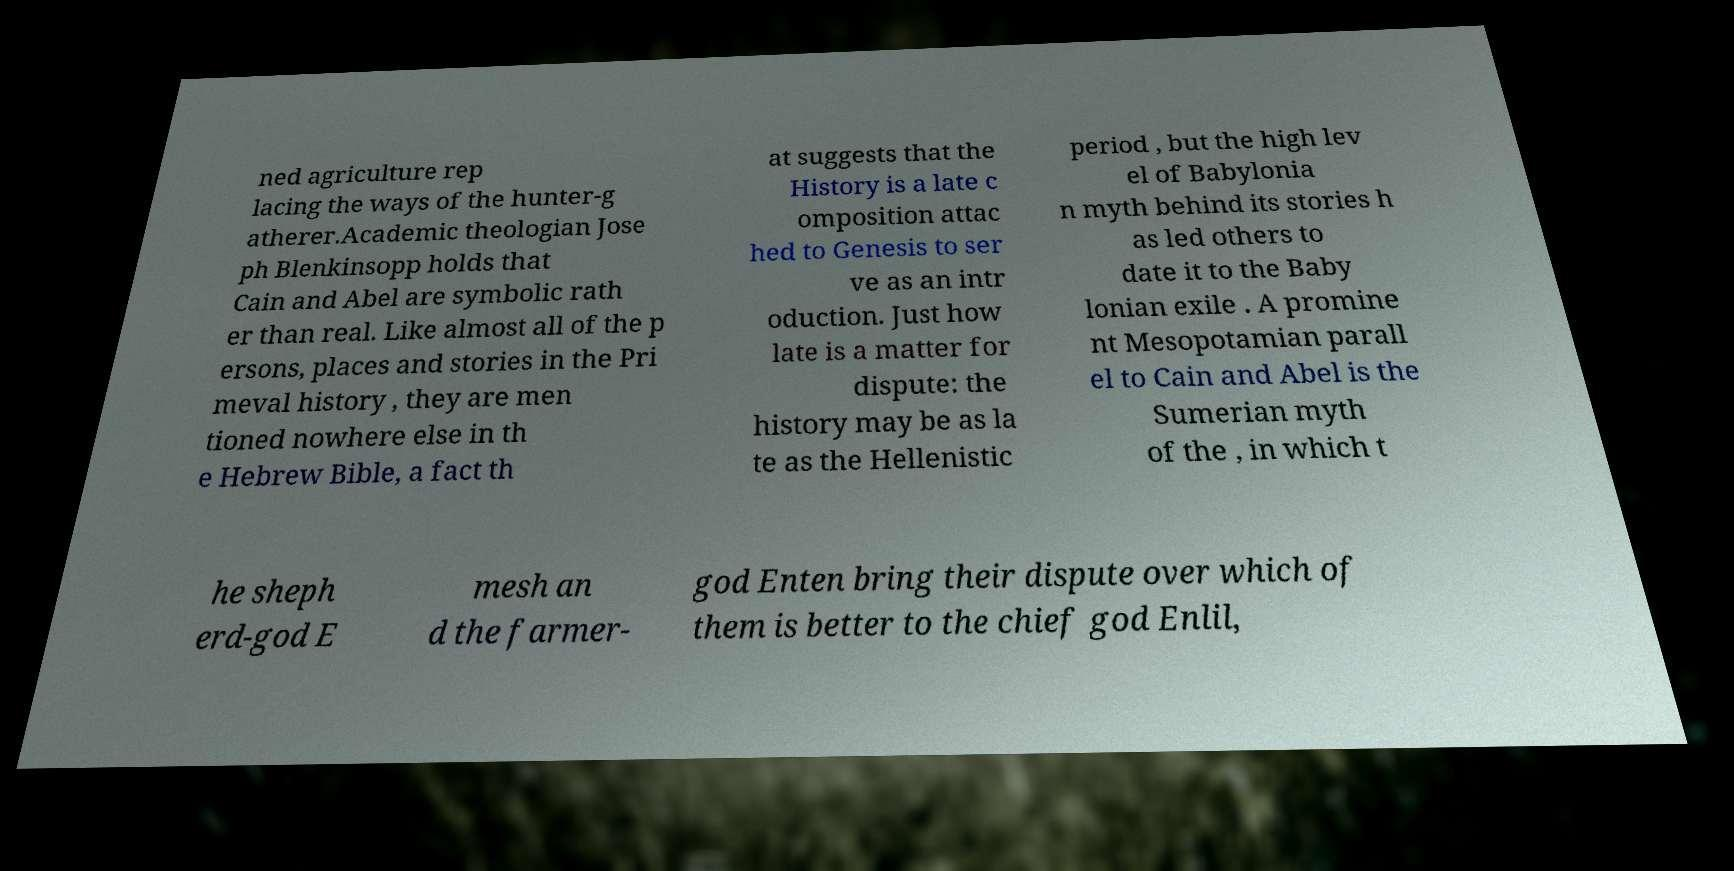What messages or text are displayed in this image? I need them in a readable, typed format. ned agriculture rep lacing the ways of the hunter-g atherer.Academic theologian Jose ph Blenkinsopp holds that Cain and Abel are symbolic rath er than real. Like almost all of the p ersons, places and stories in the Pri meval history , they are men tioned nowhere else in th e Hebrew Bible, a fact th at suggests that the History is a late c omposition attac hed to Genesis to ser ve as an intr oduction. Just how late is a matter for dispute: the history may be as la te as the Hellenistic period , but the high lev el of Babylonia n myth behind its stories h as led others to date it to the Baby lonian exile . A promine nt Mesopotamian parall el to Cain and Abel is the Sumerian myth of the , in which t he sheph erd-god E mesh an d the farmer- god Enten bring their dispute over which of them is better to the chief god Enlil, 